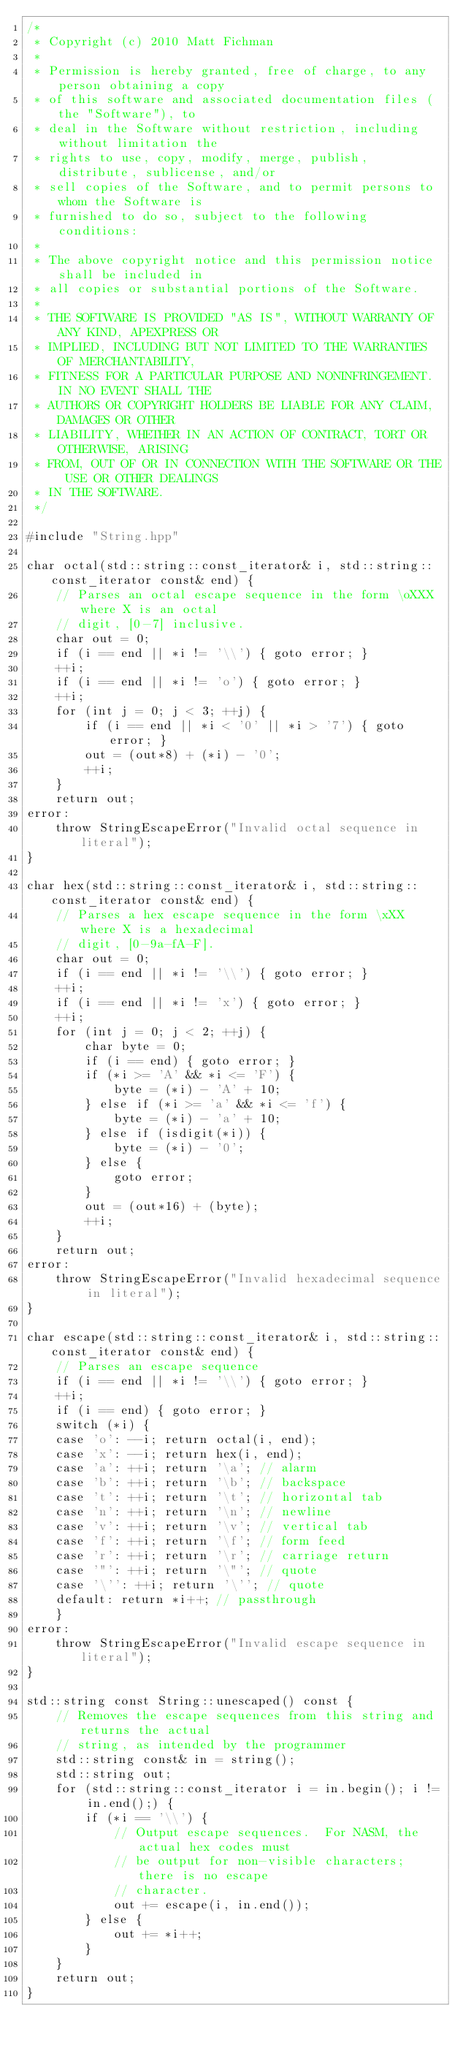<code> <loc_0><loc_0><loc_500><loc_500><_C++_>/*
 * Copyright (c) 2010 Matt Fichman
 *
 * Permission is hereby granted, free of charge, to any person obtaining a copy
 * of this software and associated documentation files (the "Software"), to
 * deal in the Software without restriction, including without limitation the
 * rights to use, copy, modify, merge, publish, distribute, sublicense, and/or
 * sell copies of the Software, and to permit persons to whom the Software is
 * furnished to do so, subject to the following conditions:
 * 
 * The above copyright notice and this permission notice shall be included in
 * all copies or substantial portions of the Software.
 * 
 * THE SOFTWARE IS PROVIDED "AS IS", WITHOUT WARRANTY OF ANY KIND, APEXPRESS OR
 * IMPLIED, INCLUDING BUT NOT LIMITED TO THE WARRANTIES OF MERCHANTABILITY,
 * FITNESS FOR A PARTICULAR PURPOSE AND NONINFRINGEMENT. IN NO EVENT SHALL THE
 * AUTHORS OR COPYRIGHT HOLDERS BE LIABLE FOR ANY CLAIM, DAMAGES OR OTHER
 * LIABILITY, WHETHER IN AN ACTION OF CONTRACT, TORT OR OTHERWISE, ARISING
 * FROM, OUT OF OR IN CONNECTION WITH THE SOFTWARE OR THE USE OR OTHER DEALINGS
 * IN THE SOFTWARE.
 */  

#include "String.hpp"

char octal(std::string::const_iterator& i, std::string::const_iterator const& end) {
    // Parses an octal escape sequence in the form \oXXX where X is an octal
    // digit, [0-7] inclusive.
    char out = 0;
    if (i == end || *i != '\\') { goto error; }
    ++i;
    if (i == end || *i != 'o') { goto error; }
    ++i;
    for (int j = 0; j < 3; ++j) {
        if (i == end || *i < '0' || *i > '7') { goto error; }
        out = (out*8) + (*i) - '0';
        ++i;
    }
    return out; 
error:
    throw StringEscapeError("Invalid octal sequence in literal");
}

char hex(std::string::const_iterator& i, std::string::const_iterator const& end) {
    // Parses a hex escape sequence in the form \xXX where X is a hexadecimal
    // digit, [0-9a-fA-F].
    char out = 0;
    if (i == end || *i != '\\') { goto error; }
    ++i;
    if (i == end || *i != 'x') { goto error; }
    ++i; 
    for (int j = 0; j < 2; ++j) {
        char byte = 0;
        if (i == end) { goto error; }
        if (*i >= 'A' && *i <= 'F') {
            byte = (*i) - 'A' + 10;
        } else if (*i >= 'a' && *i <= 'f') {
            byte = (*i) - 'a' + 10;
        } else if (isdigit(*i)) {
            byte = (*i) - '0';
        } else {
            goto error;
        }
        out = (out*16) + (byte);
        ++i;
    }
    return out;
error:
    throw StringEscapeError("Invalid hexadecimal sequence in literal");
}

char escape(std::string::const_iterator& i, std::string::const_iterator const& end) {
    // Parses an escape sequence
    if (i == end || *i != '\\') { goto error; }
    ++i;
    if (i == end) { goto error; }
    switch (*i) {
    case 'o': --i; return octal(i, end); 
    case 'x': --i; return hex(i, end); 
    case 'a': ++i; return '\a'; // alarm
    case 'b': ++i; return '\b'; // backspace
    case 't': ++i; return '\t'; // horizontal tab
    case 'n': ++i; return '\n'; // newline
    case 'v': ++i; return '\v'; // vertical tab
    case 'f': ++i; return '\f'; // form feed
    case 'r': ++i; return '\r'; // carriage return
    case '"': ++i; return '\"'; // quote
    case '\'': ++i; return '\''; // quote
    default: return *i++; // passthrough
    }
error:
    throw StringEscapeError("Invalid escape sequence in literal");
}

std::string const String::unescaped() const {
    // Removes the escape sequences from this string and returns the actual
    // string, as intended by the programmer
    std::string const& in = string();
    std::string out;
    for (std::string::const_iterator i = in.begin(); i != in.end();) {
        if (*i == '\\') {
            // Output escape sequences.  For NASM, the actual hex codes must
            // be output for non-visible characters; there is no escape
            // character.
            out += escape(i, in.end());
        } else {
            out += *i++;
        }
    }
    return out;
}
</code> 